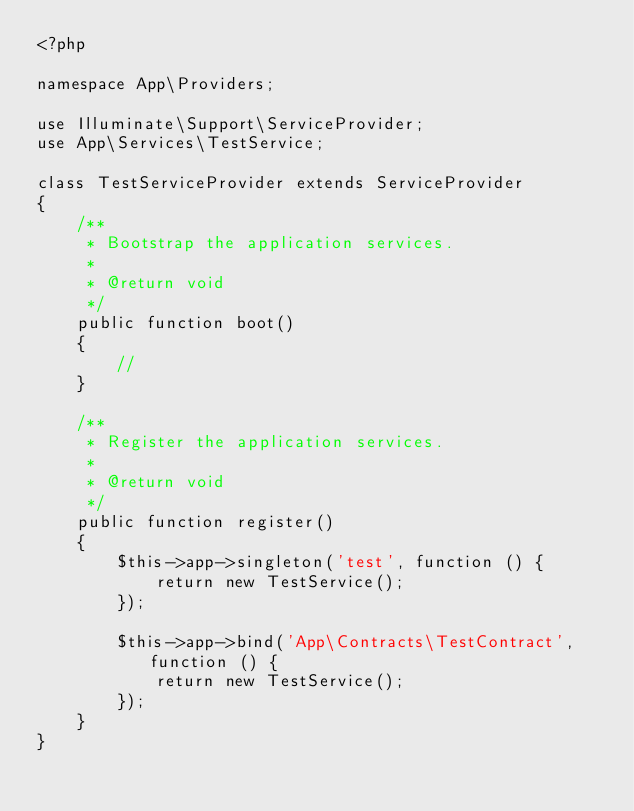<code> <loc_0><loc_0><loc_500><loc_500><_PHP_><?php

namespace App\Providers;

use Illuminate\Support\ServiceProvider;
use App\Services\TestService;

class TestServiceProvider extends ServiceProvider
{
    /**
     * Bootstrap the application services.
     *
     * @return void
     */
    public function boot()
    {
        //
    }

    /**
     * Register the application services.
     *
     * @return void
     */
    public function register()
    {
        $this->app->singleton('test', function () {
            return new TestService();
        });

        $this->app->bind('App\Contracts\TestContract', function () {
            return new TestService();
        });
    }
}
</code> 